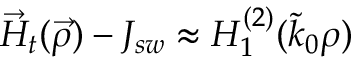<formula> <loc_0><loc_0><loc_500><loc_500>\vec { H } _ { t } ( \vec { \rho } ) - J _ { s w } \approx H _ { 1 } ^ { ( 2 ) } ( \tilde { k } _ { 0 } \rho )</formula> 